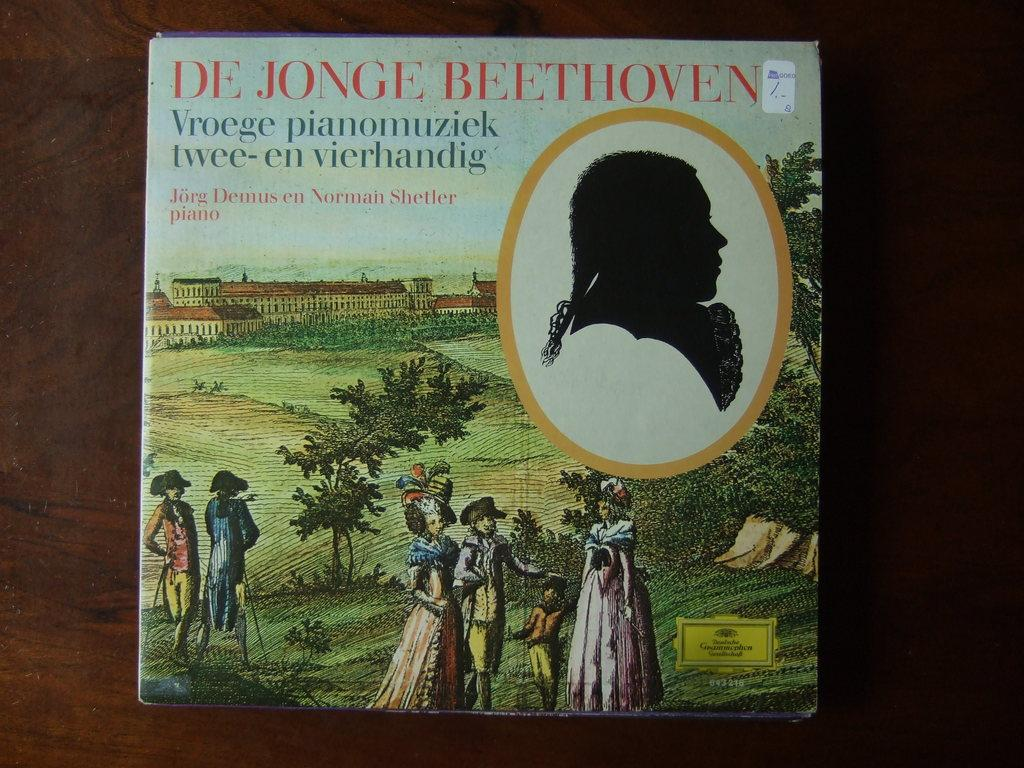<image>
Describe the image concisely. A HARD COVERED BOOK CALLED DE JONGE BEETHOVEN 